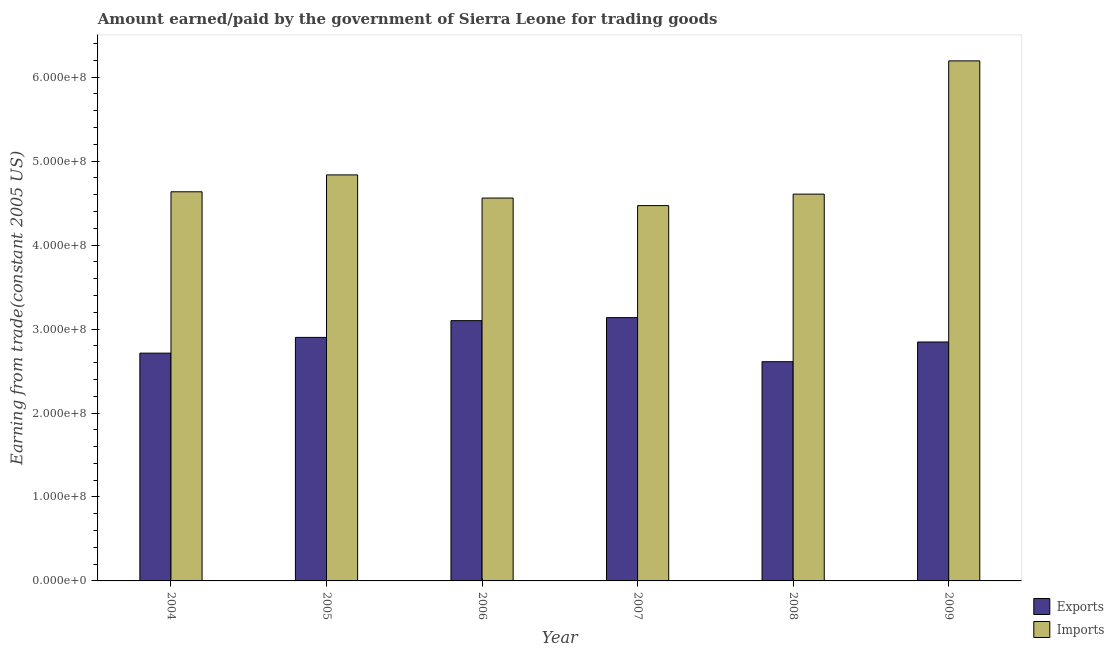Are the number of bars on each tick of the X-axis equal?
Your response must be concise. Yes. How many bars are there on the 6th tick from the left?
Your answer should be very brief. 2. In how many cases, is the number of bars for a given year not equal to the number of legend labels?
Make the answer very short. 0. What is the amount paid for imports in 2008?
Keep it short and to the point. 4.61e+08. Across all years, what is the maximum amount paid for imports?
Your answer should be compact. 6.19e+08. Across all years, what is the minimum amount earned from exports?
Make the answer very short. 2.61e+08. What is the total amount earned from exports in the graph?
Ensure brevity in your answer.  1.73e+09. What is the difference between the amount earned from exports in 2007 and that in 2008?
Your answer should be compact. 5.25e+07. What is the difference between the amount earned from exports in 2005 and the amount paid for imports in 2004?
Your answer should be compact. 1.87e+07. What is the average amount earned from exports per year?
Provide a succinct answer. 2.88e+08. What is the ratio of the amount earned from exports in 2006 to that in 2008?
Give a very brief answer. 1.19. Is the difference between the amount earned from exports in 2004 and 2009 greater than the difference between the amount paid for imports in 2004 and 2009?
Keep it short and to the point. No. What is the difference between the highest and the second highest amount paid for imports?
Provide a short and direct response. 1.36e+08. What is the difference between the highest and the lowest amount paid for imports?
Your answer should be very brief. 1.72e+08. In how many years, is the amount earned from exports greater than the average amount earned from exports taken over all years?
Offer a terse response. 3. What does the 2nd bar from the left in 2008 represents?
Provide a short and direct response. Imports. What does the 2nd bar from the right in 2006 represents?
Your answer should be compact. Exports. Does the graph contain any zero values?
Offer a very short reply. No. Where does the legend appear in the graph?
Your response must be concise. Bottom right. How are the legend labels stacked?
Keep it short and to the point. Vertical. What is the title of the graph?
Your answer should be compact. Amount earned/paid by the government of Sierra Leone for trading goods. What is the label or title of the Y-axis?
Provide a short and direct response. Earning from trade(constant 2005 US). What is the Earning from trade(constant 2005 US) of Exports in 2004?
Your answer should be compact. 2.71e+08. What is the Earning from trade(constant 2005 US) in Imports in 2004?
Give a very brief answer. 4.63e+08. What is the Earning from trade(constant 2005 US) of Exports in 2005?
Provide a succinct answer. 2.90e+08. What is the Earning from trade(constant 2005 US) in Imports in 2005?
Your answer should be compact. 4.84e+08. What is the Earning from trade(constant 2005 US) in Exports in 2006?
Offer a terse response. 3.10e+08. What is the Earning from trade(constant 2005 US) of Imports in 2006?
Provide a succinct answer. 4.56e+08. What is the Earning from trade(constant 2005 US) in Exports in 2007?
Offer a very short reply. 3.14e+08. What is the Earning from trade(constant 2005 US) of Imports in 2007?
Give a very brief answer. 4.47e+08. What is the Earning from trade(constant 2005 US) in Exports in 2008?
Offer a very short reply. 2.61e+08. What is the Earning from trade(constant 2005 US) in Imports in 2008?
Offer a terse response. 4.61e+08. What is the Earning from trade(constant 2005 US) in Exports in 2009?
Make the answer very short. 2.85e+08. What is the Earning from trade(constant 2005 US) in Imports in 2009?
Keep it short and to the point. 6.19e+08. Across all years, what is the maximum Earning from trade(constant 2005 US) of Exports?
Your answer should be very brief. 3.14e+08. Across all years, what is the maximum Earning from trade(constant 2005 US) of Imports?
Your answer should be very brief. 6.19e+08. Across all years, what is the minimum Earning from trade(constant 2005 US) in Exports?
Give a very brief answer. 2.61e+08. Across all years, what is the minimum Earning from trade(constant 2005 US) of Imports?
Make the answer very short. 4.47e+08. What is the total Earning from trade(constant 2005 US) of Exports in the graph?
Your answer should be very brief. 1.73e+09. What is the total Earning from trade(constant 2005 US) in Imports in the graph?
Offer a terse response. 2.93e+09. What is the difference between the Earning from trade(constant 2005 US) of Exports in 2004 and that in 2005?
Your answer should be compact. -1.87e+07. What is the difference between the Earning from trade(constant 2005 US) in Imports in 2004 and that in 2005?
Your answer should be compact. -2.01e+07. What is the difference between the Earning from trade(constant 2005 US) of Exports in 2004 and that in 2006?
Offer a very short reply. -3.87e+07. What is the difference between the Earning from trade(constant 2005 US) of Imports in 2004 and that in 2006?
Make the answer very short. 7.48e+06. What is the difference between the Earning from trade(constant 2005 US) of Exports in 2004 and that in 2007?
Provide a succinct answer. -4.23e+07. What is the difference between the Earning from trade(constant 2005 US) in Imports in 2004 and that in 2007?
Keep it short and to the point. 1.65e+07. What is the difference between the Earning from trade(constant 2005 US) in Exports in 2004 and that in 2008?
Give a very brief answer. 1.02e+07. What is the difference between the Earning from trade(constant 2005 US) of Imports in 2004 and that in 2008?
Your response must be concise. 2.80e+06. What is the difference between the Earning from trade(constant 2005 US) in Exports in 2004 and that in 2009?
Offer a terse response. -1.33e+07. What is the difference between the Earning from trade(constant 2005 US) in Imports in 2004 and that in 2009?
Your response must be concise. -1.56e+08. What is the difference between the Earning from trade(constant 2005 US) in Exports in 2005 and that in 2006?
Your response must be concise. -2.00e+07. What is the difference between the Earning from trade(constant 2005 US) of Imports in 2005 and that in 2006?
Offer a very short reply. 2.76e+07. What is the difference between the Earning from trade(constant 2005 US) in Exports in 2005 and that in 2007?
Give a very brief answer. -2.36e+07. What is the difference between the Earning from trade(constant 2005 US) of Imports in 2005 and that in 2007?
Provide a succinct answer. 3.66e+07. What is the difference between the Earning from trade(constant 2005 US) in Exports in 2005 and that in 2008?
Keep it short and to the point. 2.89e+07. What is the difference between the Earning from trade(constant 2005 US) in Imports in 2005 and that in 2008?
Offer a very short reply. 2.29e+07. What is the difference between the Earning from trade(constant 2005 US) in Exports in 2005 and that in 2009?
Keep it short and to the point. 5.45e+06. What is the difference between the Earning from trade(constant 2005 US) of Imports in 2005 and that in 2009?
Keep it short and to the point. -1.36e+08. What is the difference between the Earning from trade(constant 2005 US) in Exports in 2006 and that in 2007?
Provide a short and direct response. -3.61e+06. What is the difference between the Earning from trade(constant 2005 US) in Imports in 2006 and that in 2007?
Give a very brief answer. 8.99e+06. What is the difference between the Earning from trade(constant 2005 US) in Exports in 2006 and that in 2008?
Ensure brevity in your answer.  4.89e+07. What is the difference between the Earning from trade(constant 2005 US) in Imports in 2006 and that in 2008?
Your answer should be very brief. -4.68e+06. What is the difference between the Earning from trade(constant 2005 US) in Exports in 2006 and that in 2009?
Your response must be concise. 2.54e+07. What is the difference between the Earning from trade(constant 2005 US) of Imports in 2006 and that in 2009?
Offer a terse response. -1.63e+08. What is the difference between the Earning from trade(constant 2005 US) in Exports in 2007 and that in 2008?
Give a very brief answer. 5.25e+07. What is the difference between the Earning from trade(constant 2005 US) of Imports in 2007 and that in 2008?
Your answer should be very brief. -1.37e+07. What is the difference between the Earning from trade(constant 2005 US) in Exports in 2007 and that in 2009?
Ensure brevity in your answer.  2.90e+07. What is the difference between the Earning from trade(constant 2005 US) of Imports in 2007 and that in 2009?
Your answer should be very brief. -1.72e+08. What is the difference between the Earning from trade(constant 2005 US) in Exports in 2008 and that in 2009?
Provide a succinct answer. -2.35e+07. What is the difference between the Earning from trade(constant 2005 US) of Imports in 2008 and that in 2009?
Provide a succinct answer. -1.59e+08. What is the difference between the Earning from trade(constant 2005 US) in Exports in 2004 and the Earning from trade(constant 2005 US) in Imports in 2005?
Keep it short and to the point. -2.12e+08. What is the difference between the Earning from trade(constant 2005 US) of Exports in 2004 and the Earning from trade(constant 2005 US) of Imports in 2006?
Your response must be concise. -1.85e+08. What is the difference between the Earning from trade(constant 2005 US) of Exports in 2004 and the Earning from trade(constant 2005 US) of Imports in 2007?
Offer a very short reply. -1.76e+08. What is the difference between the Earning from trade(constant 2005 US) of Exports in 2004 and the Earning from trade(constant 2005 US) of Imports in 2008?
Ensure brevity in your answer.  -1.89e+08. What is the difference between the Earning from trade(constant 2005 US) of Exports in 2004 and the Earning from trade(constant 2005 US) of Imports in 2009?
Provide a short and direct response. -3.48e+08. What is the difference between the Earning from trade(constant 2005 US) of Exports in 2005 and the Earning from trade(constant 2005 US) of Imports in 2006?
Offer a very short reply. -1.66e+08. What is the difference between the Earning from trade(constant 2005 US) in Exports in 2005 and the Earning from trade(constant 2005 US) in Imports in 2007?
Your response must be concise. -1.57e+08. What is the difference between the Earning from trade(constant 2005 US) of Exports in 2005 and the Earning from trade(constant 2005 US) of Imports in 2008?
Your answer should be very brief. -1.71e+08. What is the difference between the Earning from trade(constant 2005 US) in Exports in 2005 and the Earning from trade(constant 2005 US) in Imports in 2009?
Give a very brief answer. -3.29e+08. What is the difference between the Earning from trade(constant 2005 US) in Exports in 2006 and the Earning from trade(constant 2005 US) in Imports in 2007?
Your answer should be compact. -1.37e+08. What is the difference between the Earning from trade(constant 2005 US) of Exports in 2006 and the Earning from trade(constant 2005 US) of Imports in 2008?
Ensure brevity in your answer.  -1.51e+08. What is the difference between the Earning from trade(constant 2005 US) of Exports in 2006 and the Earning from trade(constant 2005 US) of Imports in 2009?
Offer a terse response. -3.09e+08. What is the difference between the Earning from trade(constant 2005 US) in Exports in 2007 and the Earning from trade(constant 2005 US) in Imports in 2008?
Provide a short and direct response. -1.47e+08. What is the difference between the Earning from trade(constant 2005 US) of Exports in 2007 and the Earning from trade(constant 2005 US) of Imports in 2009?
Offer a terse response. -3.06e+08. What is the difference between the Earning from trade(constant 2005 US) of Exports in 2008 and the Earning from trade(constant 2005 US) of Imports in 2009?
Provide a succinct answer. -3.58e+08. What is the average Earning from trade(constant 2005 US) of Exports per year?
Your answer should be very brief. 2.88e+08. What is the average Earning from trade(constant 2005 US) in Imports per year?
Offer a terse response. 4.88e+08. In the year 2004, what is the difference between the Earning from trade(constant 2005 US) of Exports and Earning from trade(constant 2005 US) of Imports?
Your response must be concise. -1.92e+08. In the year 2005, what is the difference between the Earning from trade(constant 2005 US) of Exports and Earning from trade(constant 2005 US) of Imports?
Provide a short and direct response. -1.94e+08. In the year 2006, what is the difference between the Earning from trade(constant 2005 US) in Exports and Earning from trade(constant 2005 US) in Imports?
Ensure brevity in your answer.  -1.46e+08. In the year 2007, what is the difference between the Earning from trade(constant 2005 US) in Exports and Earning from trade(constant 2005 US) in Imports?
Offer a very short reply. -1.33e+08. In the year 2008, what is the difference between the Earning from trade(constant 2005 US) in Exports and Earning from trade(constant 2005 US) in Imports?
Provide a succinct answer. -2.00e+08. In the year 2009, what is the difference between the Earning from trade(constant 2005 US) in Exports and Earning from trade(constant 2005 US) in Imports?
Offer a very short reply. -3.35e+08. What is the ratio of the Earning from trade(constant 2005 US) of Exports in 2004 to that in 2005?
Keep it short and to the point. 0.94. What is the ratio of the Earning from trade(constant 2005 US) of Imports in 2004 to that in 2005?
Ensure brevity in your answer.  0.96. What is the ratio of the Earning from trade(constant 2005 US) in Exports in 2004 to that in 2006?
Your response must be concise. 0.88. What is the ratio of the Earning from trade(constant 2005 US) in Imports in 2004 to that in 2006?
Your answer should be very brief. 1.02. What is the ratio of the Earning from trade(constant 2005 US) in Exports in 2004 to that in 2007?
Make the answer very short. 0.87. What is the ratio of the Earning from trade(constant 2005 US) of Imports in 2004 to that in 2007?
Provide a succinct answer. 1.04. What is the ratio of the Earning from trade(constant 2005 US) of Exports in 2004 to that in 2008?
Offer a terse response. 1.04. What is the ratio of the Earning from trade(constant 2005 US) in Exports in 2004 to that in 2009?
Provide a short and direct response. 0.95. What is the ratio of the Earning from trade(constant 2005 US) in Imports in 2004 to that in 2009?
Offer a terse response. 0.75. What is the ratio of the Earning from trade(constant 2005 US) in Exports in 2005 to that in 2006?
Offer a very short reply. 0.94. What is the ratio of the Earning from trade(constant 2005 US) in Imports in 2005 to that in 2006?
Offer a terse response. 1.06. What is the ratio of the Earning from trade(constant 2005 US) in Exports in 2005 to that in 2007?
Your answer should be compact. 0.92. What is the ratio of the Earning from trade(constant 2005 US) of Imports in 2005 to that in 2007?
Your answer should be very brief. 1.08. What is the ratio of the Earning from trade(constant 2005 US) in Exports in 2005 to that in 2008?
Ensure brevity in your answer.  1.11. What is the ratio of the Earning from trade(constant 2005 US) of Imports in 2005 to that in 2008?
Offer a very short reply. 1.05. What is the ratio of the Earning from trade(constant 2005 US) in Exports in 2005 to that in 2009?
Provide a succinct answer. 1.02. What is the ratio of the Earning from trade(constant 2005 US) of Imports in 2005 to that in 2009?
Your answer should be compact. 0.78. What is the ratio of the Earning from trade(constant 2005 US) of Imports in 2006 to that in 2007?
Your response must be concise. 1.02. What is the ratio of the Earning from trade(constant 2005 US) of Exports in 2006 to that in 2008?
Provide a short and direct response. 1.19. What is the ratio of the Earning from trade(constant 2005 US) of Exports in 2006 to that in 2009?
Make the answer very short. 1.09. What is the ratio of the Earning from trade(constant 2005 US) of Imports in 2006 to that in 2009?
Offer a very short reply. 0.74. What is the ratio of the Earning from trade(constant 2005 US) in Exports in 2007 to that in 2008?
Offer a very short reply. 1.2. What is the ratio of the Earning from trade(constant 2005 US) in Imports in 2007 to that in 2008?
Your answer should be very brief. 0.97. What is the ratio of the Earning from trade(constant 2005 US) in Exports in 2007 to that in 2009?
Offer a very short reply. 1.1. What is the ratio of the Earning from trade(constant 2005 US) in Imports in 2007 to that in 2009?
Make the answer very short. 0.72. What is the ratio of the Earning from trade(constant 2005 US) of Exports in 2008 to that in 2009?
Provide a succinct answer. 0.92. What is the ratio of the Earning from trade(constant 2005 US) in Imports in 2008 to that in 2009?
Your response must be concise. 0.74. What is the difference between the highest and the second highest Earning from trade(constant 2005 US) in Exports?
Keep it short and to the point. 3.61e+06. What is the difference between the highest and the second highest Earning from trade(constant 2005 US) of Imports?
Ensure brevity in your answer.  1.36e+08. What is the difference between the highest and the lowest Earning from trade(constant 2005 US) in Exports?
Ensure brevity in your answer.  5.25e+07. What is the difference between the highest and the lowest Earning from trade(constant 2005 US) of Imports?
Your answer should be very brief. 1.72e+08. 